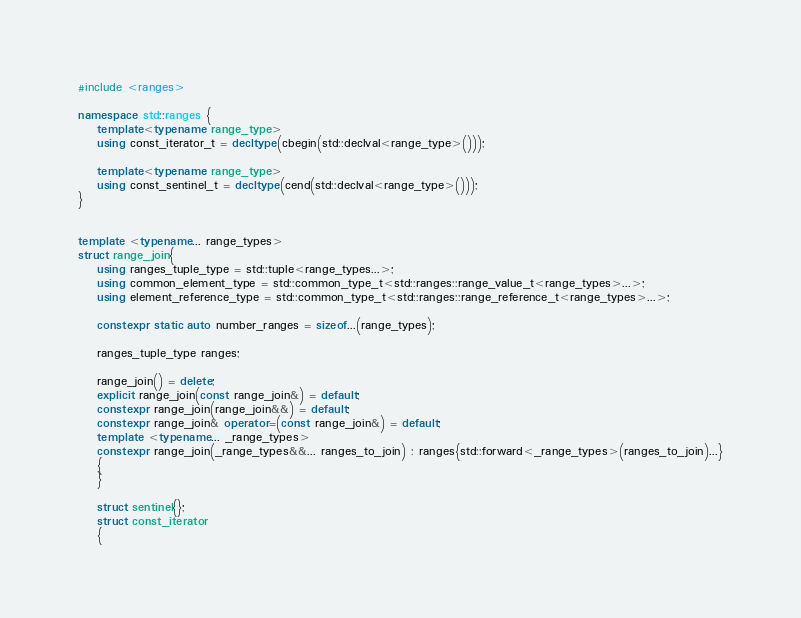<code> <loc_0><loc_0><loc_500><loc_500><_C++_>#include <ranges>

namespace std::ranges {
    template<typename range_type>
    using const_iterator_t = decltype(cbegin(std::declval<range_type>()));

    template<typename range_type>
    using const_sentinel_t = decltype(cend(std::declval<range_type>()));
}


template <typename... range_types>
struct range_join{
    using ranges_tuple_type = std::tuple<range_types...>;
    using common_element_type = std::common_type_t<std::ranges::range_value_t<range_types>...>;
    using element_reference_type = std::common_type_t<std::ranges::range_reference_t<range_types>...>;

    constexpr static auto number_ranges = sizeof...(range_types);

    ranges_tuple_type ranges;

    range_join() = delete;
    explicit range_join(const range_join&) = default;
    constexpr range_join(range_join&&) = default;
    constexpr range_join& operator=(const range_join&) = default;
    template <typename... _range_types>
    constexpr range_join(_range_types&&... ranges_to_join) : ranges{std::forward<_range_types>(ranges_to_join)...}
    {
    }

    struct sentinel{};
    struct const_iterator
    {</code> 